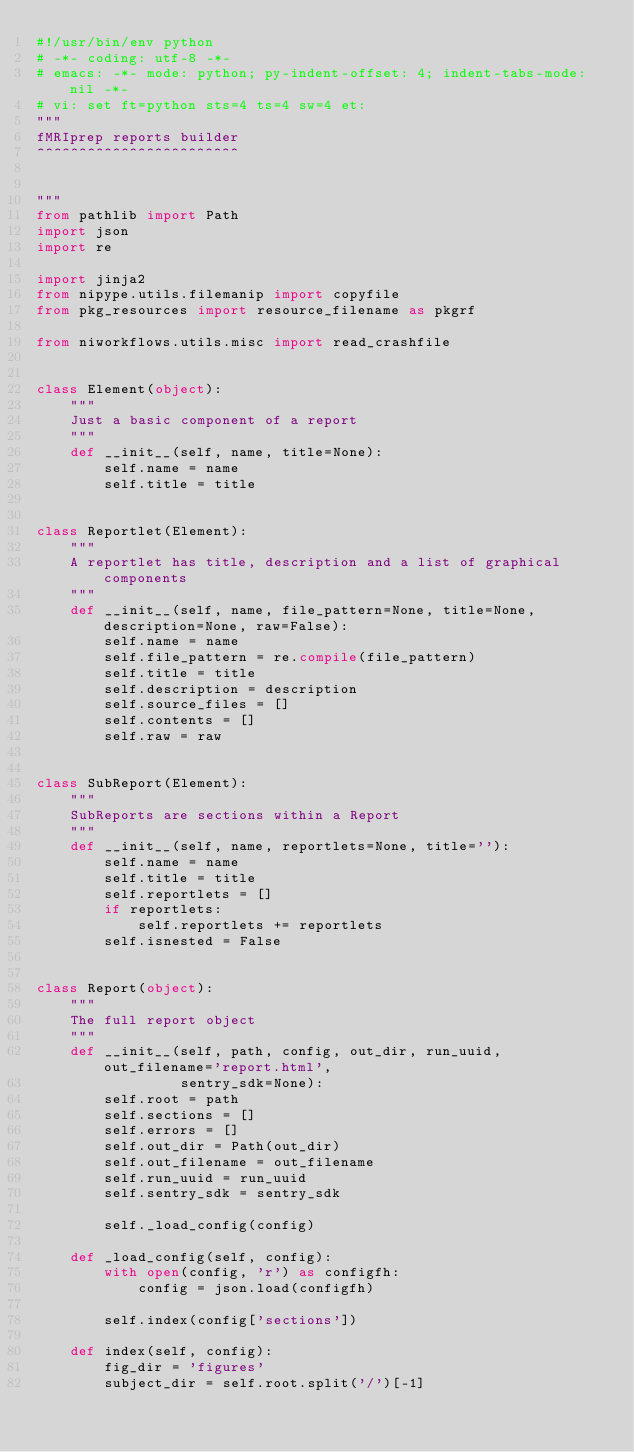Convert code to text. <code><loc_0><loc_0><loc_500><loc_500><_Python_>#!/usr/bin/env python
# -*- coding: utf-8 -*-
# emacs: -*- mode: python; py-indent-offset: 4; indent-tabs-mode: nil -*-
# vi: set ft=python sts=4 ts=4 sw=4 et:
"""
fMRIprep reports builder
^^^^^^^^^^^^^^^^^^^^^^^^


"""
from pathlib import Path
import json
import re

import jinja2
from nipype.utils.filemanip import copyfile
from pkg_resources import resource_filename as pkgrf

from niworkflows.utils.misc import read_crashfile


class Element(object):
    """
    Just a basic component of a report
    """
    def __init__(self, name, title=None):
        self.name = name
        self.title = title


class Reportlet(Element):
    """
    A reportlet has title, description and a list of graphical components
    """
    def __init__(self, name, file_pattern=None, title=None, description=None, raw=False):
        self.name = name
        self.file_pattern = re.compile(file_pattern)
        self.title = title
        self.description = description
        self.source_files = []
        self.contents = []
        self.raw = raw


class SubReport(Element):
    """
    SubReports are sections within a Report
    """
    def __init__(self, name, reportlets=None, title=''):
        self.name = name
        self.title = title
        self.reportlets = []
        if reportlets:
            self.reportlets += reportlets
        self.isnested = False


class Report(object):
    """
    The full report object
    """
    def __init__(self, path, config, out_dir, run_uuid, out_filename='report.html',
                 sentry_sdk=None):
        self.root = path
        self.sections = []
        self.errors = []
        self.out_dir = Path(out_dir)
        self.out_filename = out_filename
        self.run_uuid = run_uuid
        self.sentry_sdk = sentry_sdk

        self._load_config(config)

    def _load_config(self, config):
        with open(config, 'r') as configfh:
            config = json.load(configfh)

        self.index(config['sections'])

    def index(self, config):
        fig_dir = 'figures'
        subject_dir = self.root.split('/')[-1]</code> 